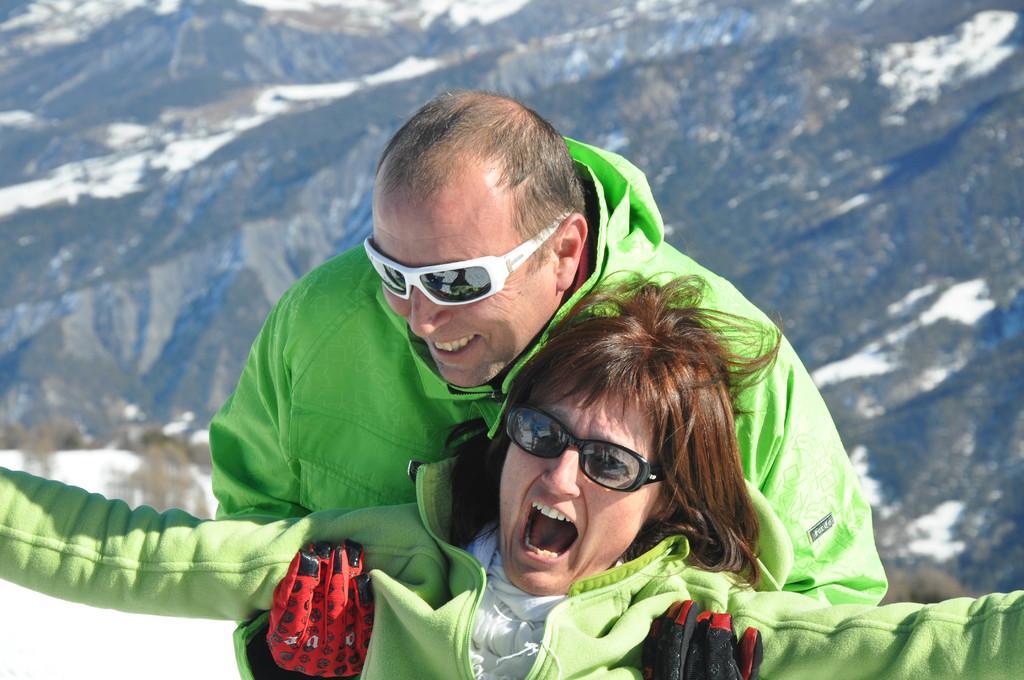In one or two sentences, can you explain what this image depicts? There is a person in green color coat wearing sunglasses, smiling and holding a woman who is in green color coat and is laughing. In the background, there are trees and snow on the mountains. 